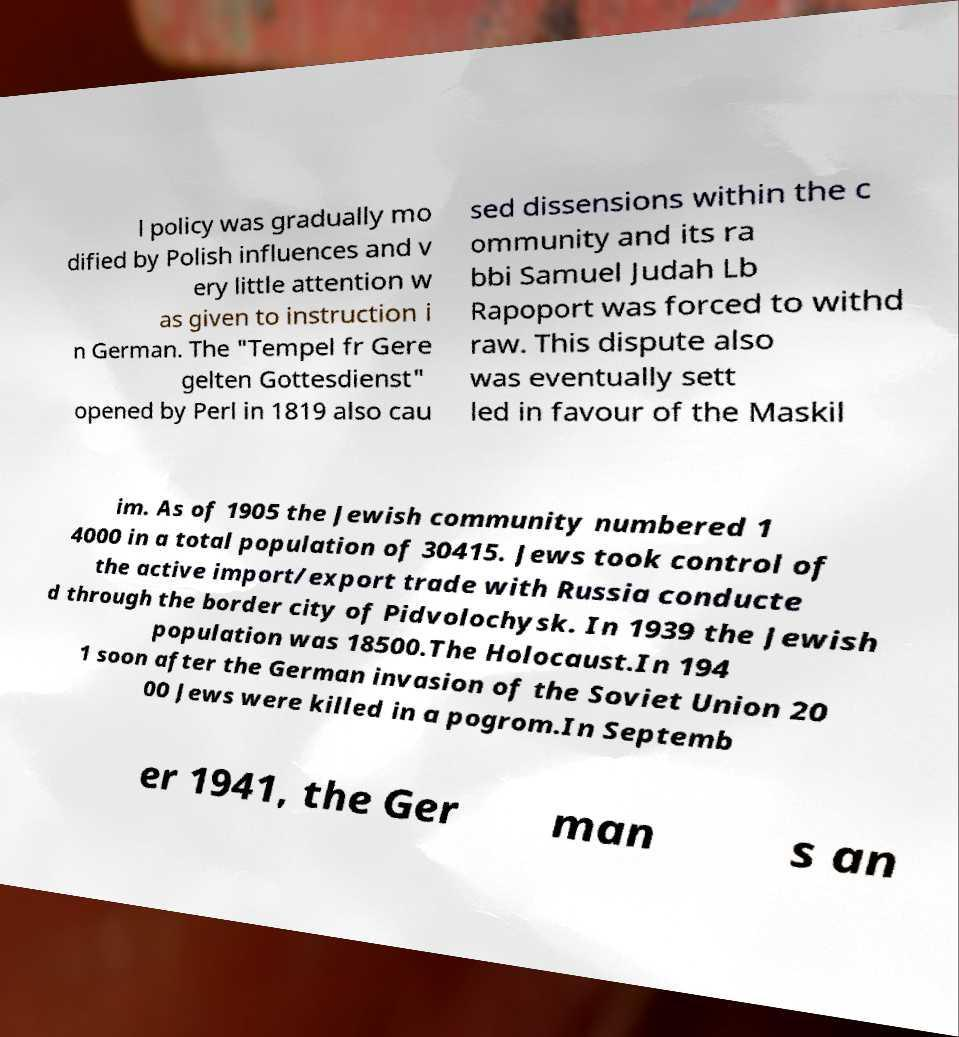I need the written content from this picture converted into text. Can you do that? l policy was gradually mo dified by Polish influences and v ery little attention w as given to instruction i n German. The "Tempel fr Gere gelten Gottesdienst" opened by Perl in 1819 also cau sed dissensions within the c ommunity and its ra bbi Samuel Judah Lb Rapoport was forced to withd raw. This dispute also was eventually sett led in favour of the Maskil im. As of 1905 the Jewish community numbered 1 4000 in a total population of 30415. Jews took control of the active import/export trade with Russia conducte d through the border city of Pidvolochysk. In 1939 the Jewish population was 18500.The Holocaust.In 194 1 soon after the German invasion of the Soviet Union 20 00 Jews were killed in a pogrom.In Septemb er 1941, the Ger man s an 